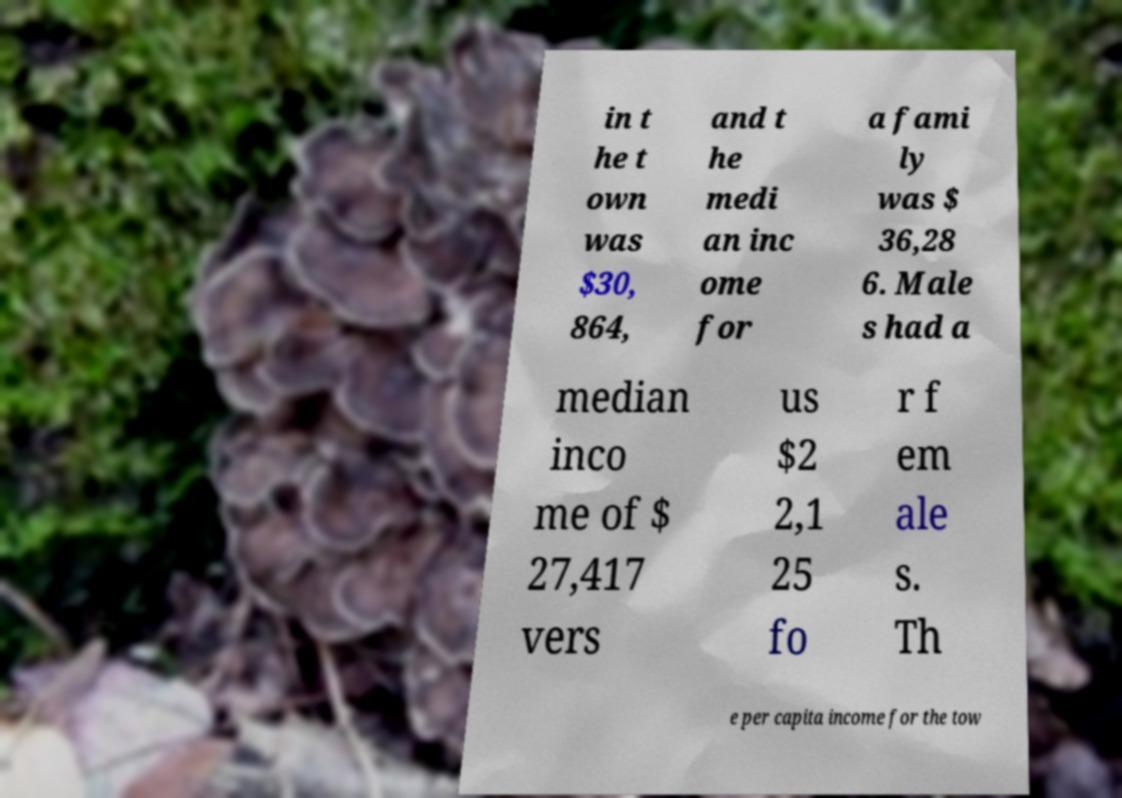There's text embedded in this image that I need extracted. Can you transcribe it verbatim? in t he t own was $30, 864, and t he medi an inc ome for a fami ly was $ 36,28 6. Male s had a median inco me of $ 27,417 vers us $2 2,1 25 fo r f em ale s. Th e per capita income for the tow 